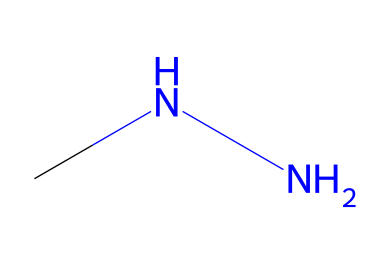What is the chemical name of this compound? The chemical is identified as monomethylhydrazine, indicated by the structure comprising a hydrazine backbone with a methyl group attached to one of the nitrogen atoms.
Answer: monomethylhydrazine How many nitrogen atoms does this molecule contain? The structure shows two nitrogen atoms, which are part of the hydrazine functional group (N-N), indicated in the connected sequence of the molecule.
Answer: two What is the oxidation state of nitrogen in this compound? Each nitrogen atom in monomethylhydrazine has an oxidation state of -2. This is derived from the bonding configuration with hydrogens and their position in the structure.
Answer: -2 How many hydrogen atoms are present in this molecule? The molecule consists of six hydrogen atoms, as counted through assessing the connectivity of nitrogen and the methyl group that each contributes hydrogen.
Answer: six What type of bonding is primarily found in this structure? The primary bonding in monomethylhydrazine is covalent, as seen through the sharing of electron pairs between nitrogen and hydrogen atoms, and between the nitrogen atoms themselves.
Answer: covalent Is this compound considered a fuel? Yes, monomethylhydrazine is classified as a rocket fuel due to its high-energy density and efficient propellant characteristics in aerospace applications.
Answer: yes What functional group is present in this molecule? The functional group present in monomethylhydrazine is the hydrazine group (N-N), which is characteristic of compounds derived from hydrazines and determines its specific chemical behavior.
Answer: hydrazine 